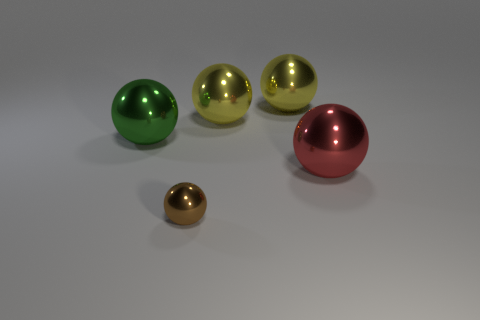There is a metallic sphere left of the small brown metal thing; what number of big yellow objects are behind it?
Your answer should be compact. 2. How many metallic things are both behind the brown metal object and to the right of the big green metallic ball?
Give a very brief answer. 3. What number of things are red shiny spheres that are in front of the big green metal object or yellow shiny spheres to the right of the small metallic thing?
Ensure brevity in your answer.  3. How many other things are there of the same size as the brown thing?
Your answer should be very brief. 0. What is the color of the small sphere?
Make the answer very short. Brown. Are any purple metallic cubes visible?
Give a very brief answer. No. Are there any things behind the brown object?
Give a very brief answer. Yes. What number of other objects are the same shape as the green metal object?
Offer a terse response. 4. How many yellow things are in front of the large sphere in front of the green metal object that is to the left of the tiny brown object?
Provide a succinct answer. 0. What number of other large green shiny objects have the same shape as the large green metallic thing?
Give a very brief answer. 0. 